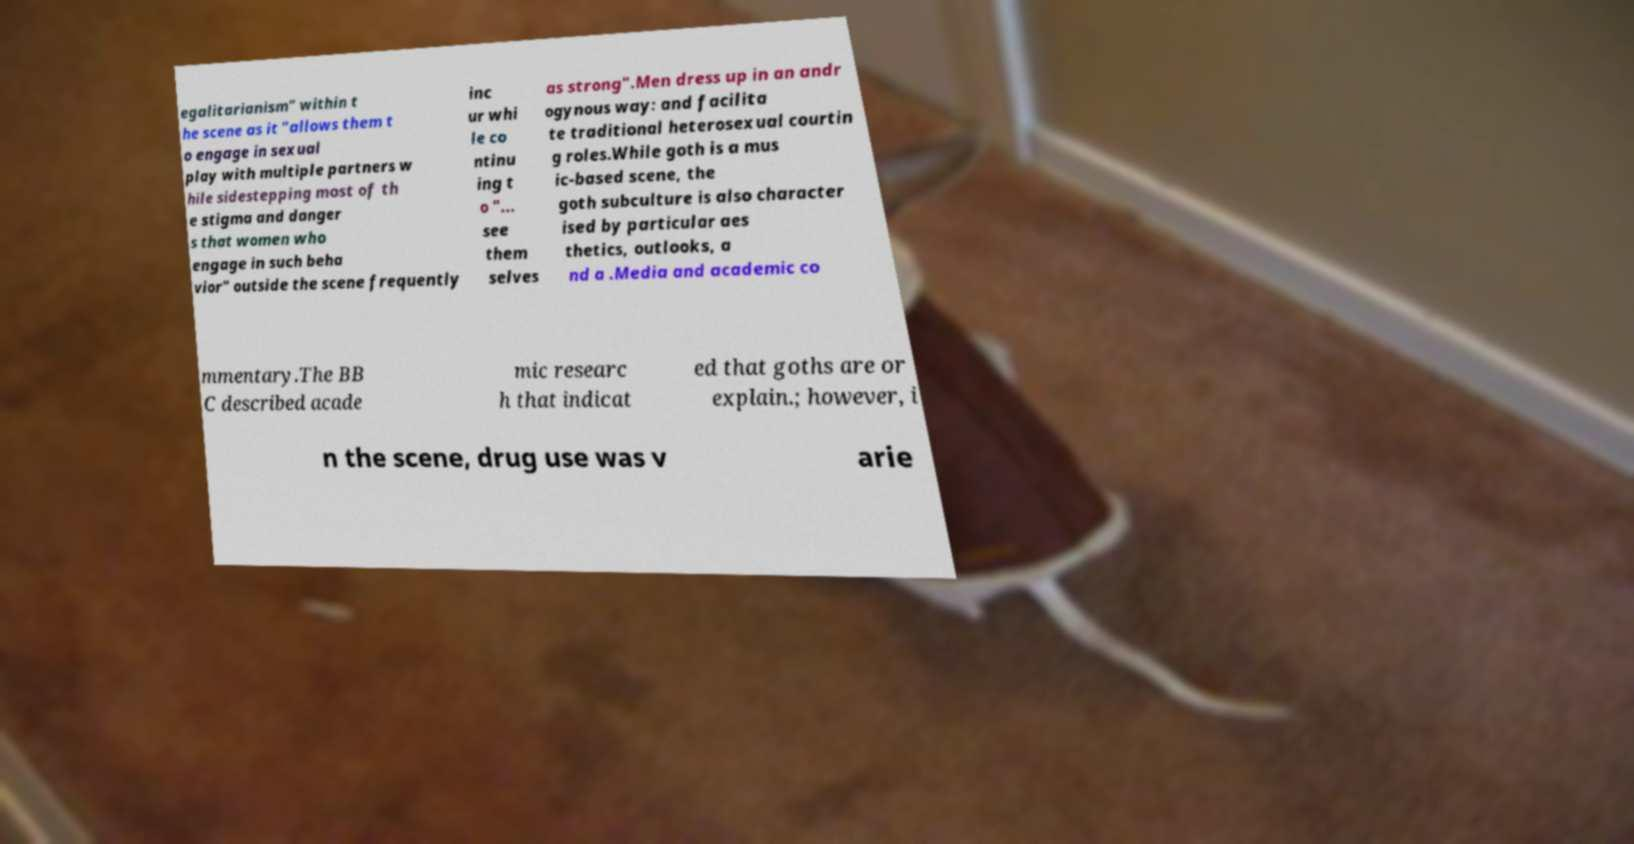Please identify and transcribe the text found in this image. egalitarianism" within t he scene as it "allows them t o engage in sexual play with multiple partners w hile sidestepping most of th e stigma and danger s that women who engage in such beha vior" outside the scene frequently inc ur whi le co ntinu ing t o "... see them selves as strong".Men dress up in an andr ogynous way: and facilita te traditional heterosexual courtin g roles.While goth is a mus ic-based scene, the goth subculture is also character ised by particular aes thetics, outlooks, a nd a .Media and academic co mmentary.The BB C described acade mic researc h that indicat ed that goths are or explain.; however, i n the scene, drug use was v arie 